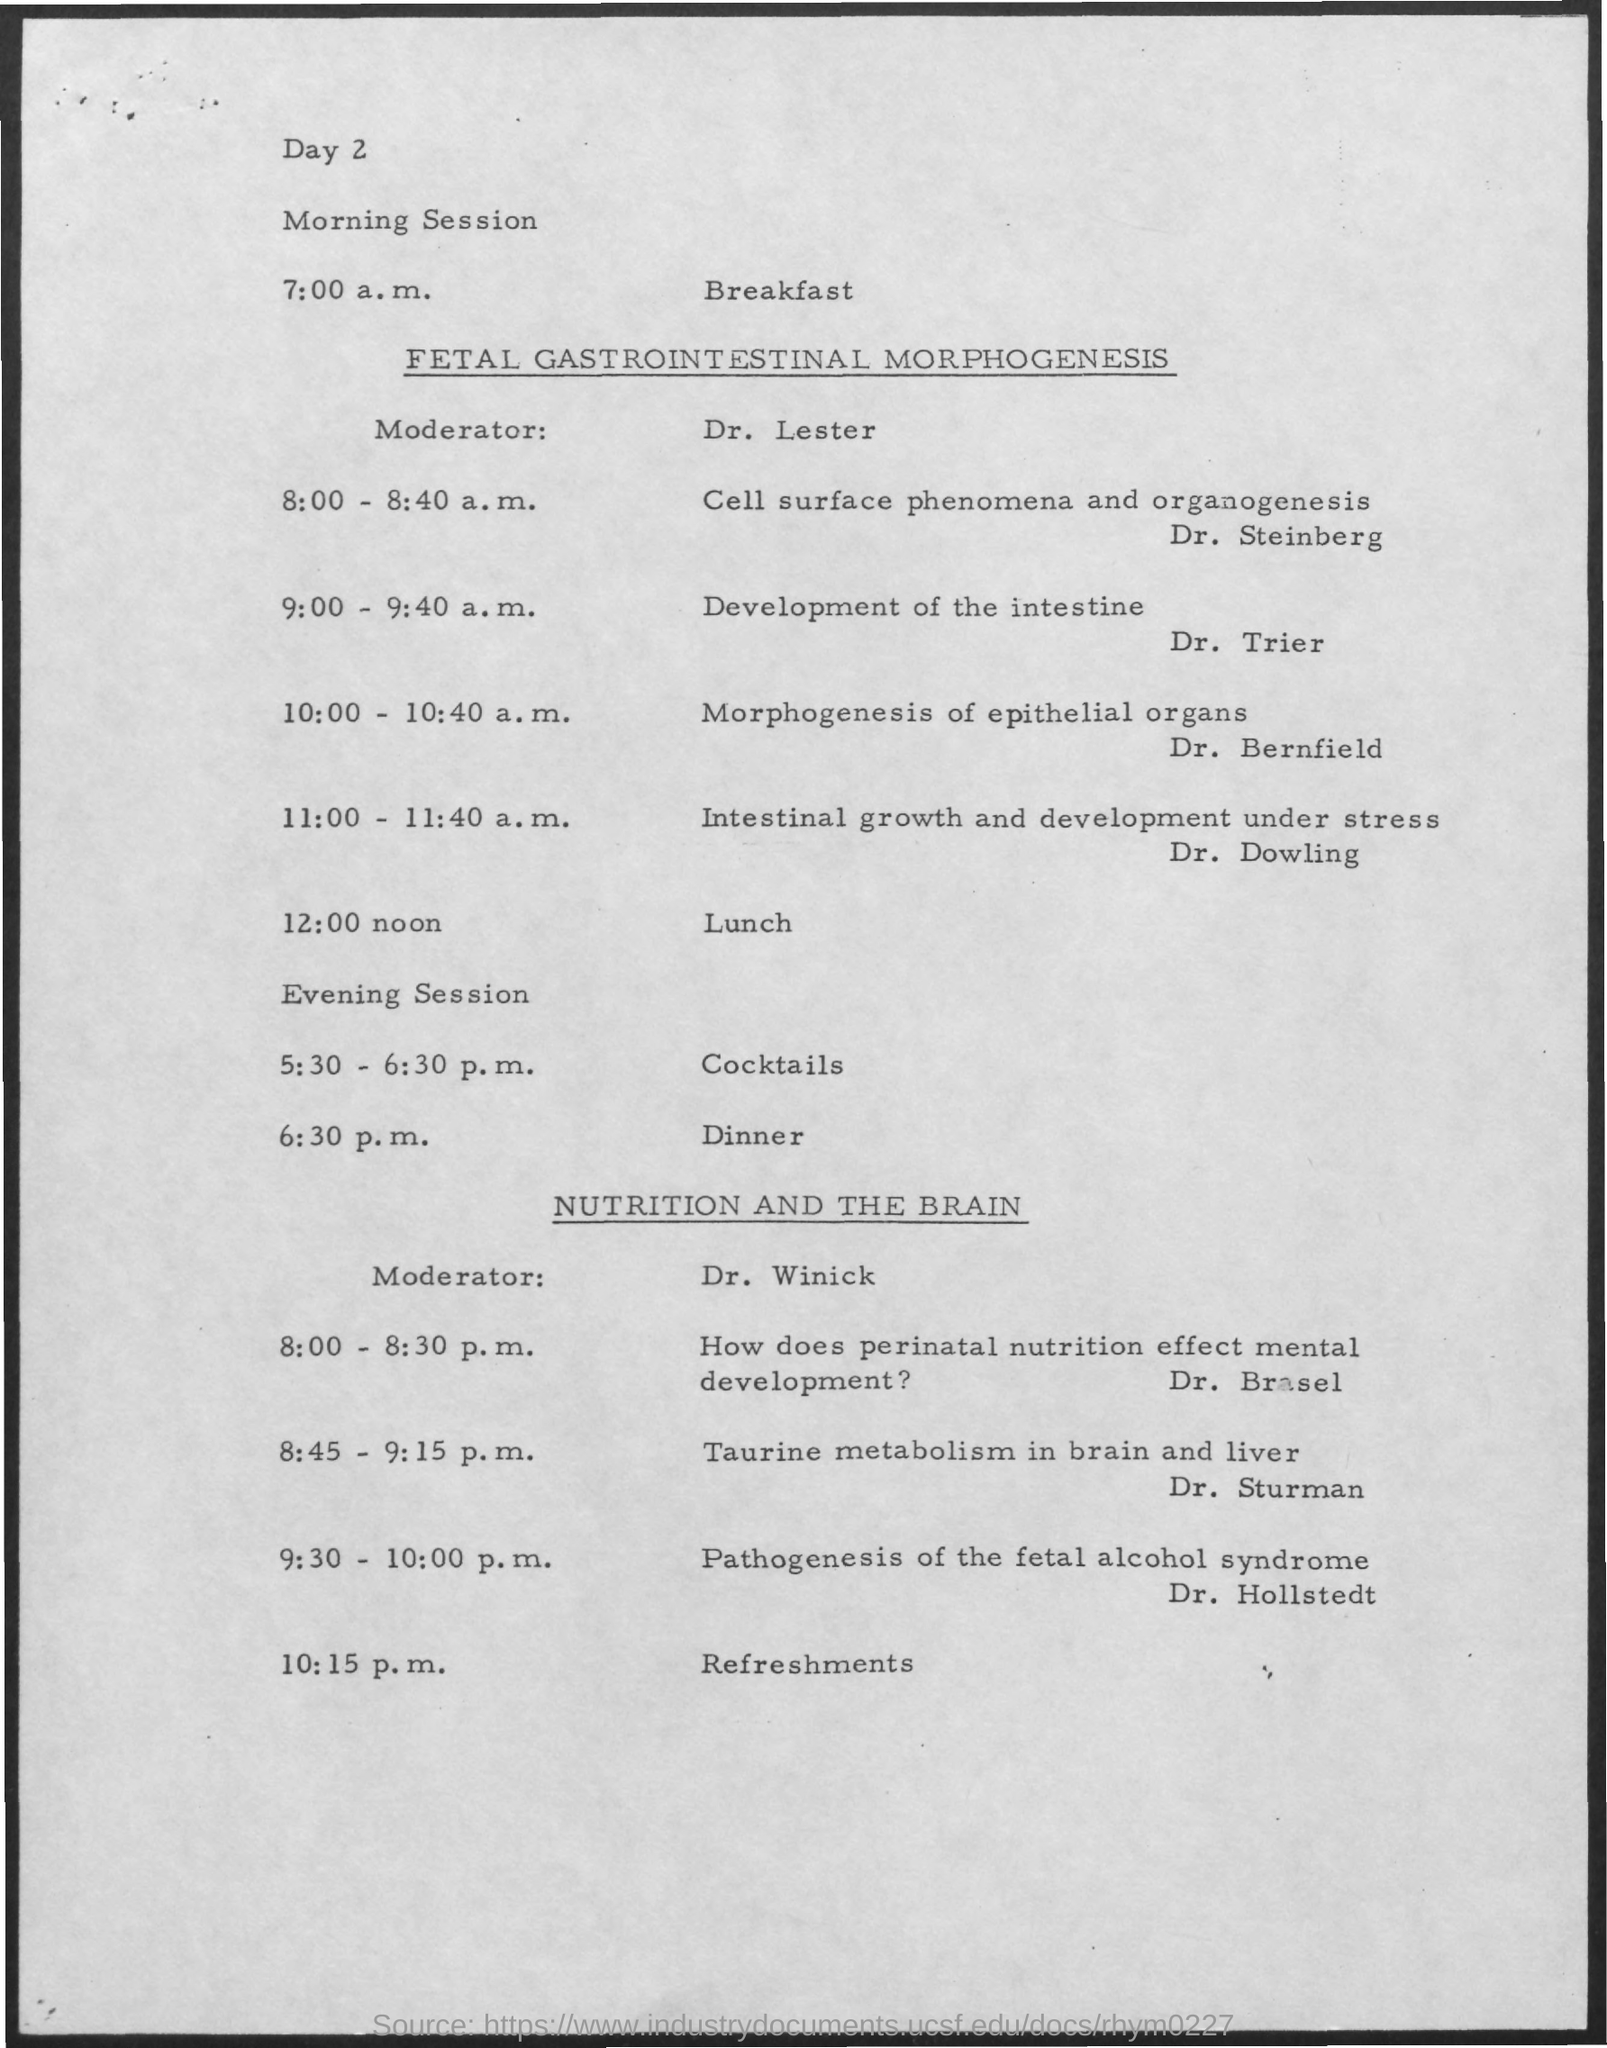What is the morning session about?
Offer a very short reply. FETAL GASTROINTESTINAL MORPHOGENESIS. Who is the moderator for morning session?
Your response must be concise. Dr. Lester. What is Dr. Trier's topic?
Offer a terse response. Development of the intestine. Who is talking about Morphogenesis of epithelial organs?
Your answer should be compact. Dr. Bernfield. What is the topic from 8:45-9:15 p.m.?
Provide a short and direct response. Taurine metabolism in brain and liver. At what time is the dinner?
Make the answer very short. 6:30 p.m. Who is the last speaker for the day?
Your response must be concise. Dr. Hollstedt. 